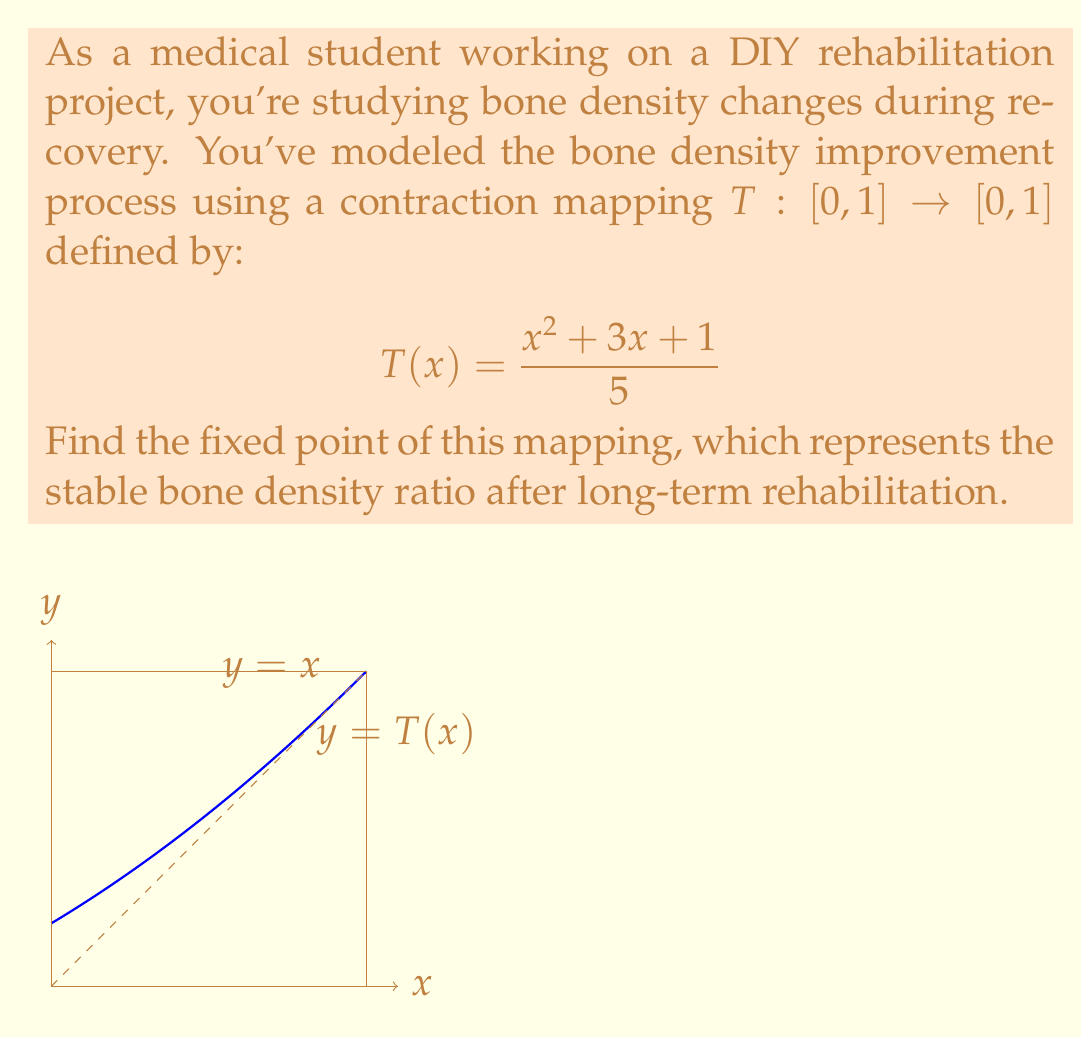Can you solve this math problem? Let's approach this step-by-step:

1) A fixed point $x^*$ of the mapping $T$ satisfies $T(x^*) = x^*$. So, we need to solve the equation:

   $$x = \frac{x^2 + 3x + 1}{5}$$

2) Multiply both sides by 5:

   $$5x = x^2 + 3x + 1$$

3) Rearrange the equation:

   $$x^2 - 2x + 1 = 0$$

4) This is a quadratic equation. We can solve it using the quadratic formula:

   $$x = \frac{-b \pm \sqrt{b^2 - 4ac}}{2a}$$

   where $a=1$, $b=-2$, and $c=1$

5) Substituting these values:

   $$x = \frac{2 \pm \sqrt{4 - 4}}{2} = \frac{2 \pm 0}{2} = 1$$

6) Therefore, the fixed point is $x^* = 1$.

7) We can verify this by plugging it back into the original function:

   $$T(1) = \frac{1^2 + 3(1) + 1}{5} = \frac{5}{5} = 1$$

8) Note that this fixed point is in the domain $[0,1]$, which is consistent with our bone density ratio model.
Answer: $x^* = 1$ 